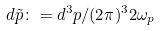<formula> <loc_0><loc_0><loc_500><loc_500>d { \tilde { p } } \colon = d ^ { 3 } p / ( 2 \pi ) ^ { 3 } 2 \omega _ { p }</formula> 